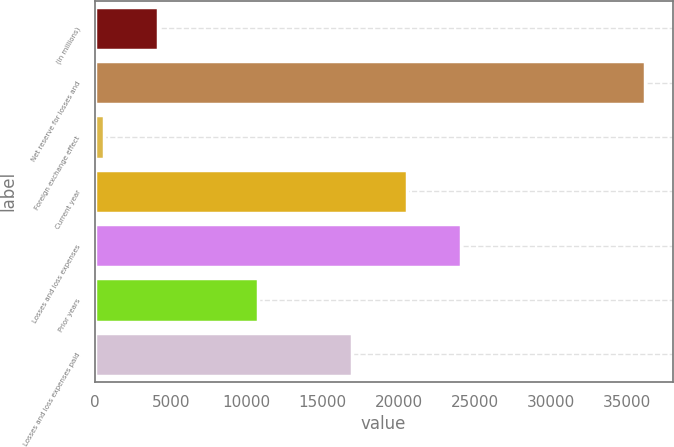Convert chart. <chart><loc_0><loc_0><loc_500><loc_500><bar_chart><fcel>(in millions)<fcel>Net reserve for losses and<fcel>Foreign exchange effect<fcel>Current year<fcel>Losses and loss expenses<fcel>Prior years<fcel>Losses and loss expenses paid<nl><fcel>4144.8<fcel>36228<fcel>580<fcel>20526.8<fcel>24091.6<fcel>10775<fcel>16962<nl></chart> 